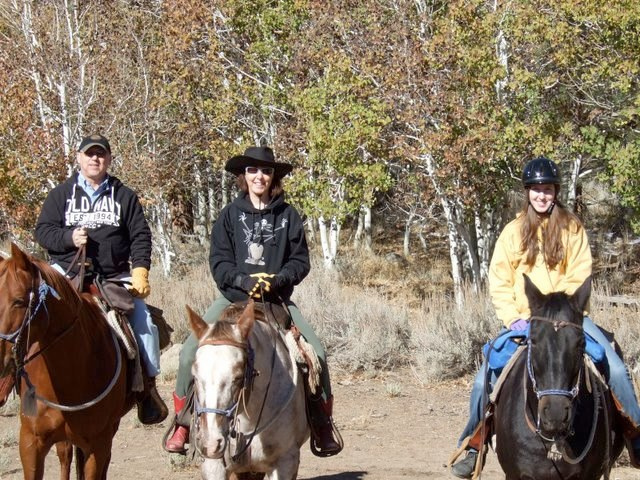What is the name of a person who rides these animals in races? A person who rides horses in races is commonly known as a jockey. Jockeys are athletes who must maintain a light body weight and often have to strategize how to lead their horse to victory in the competitive, fast-paced sport of horse racing. 